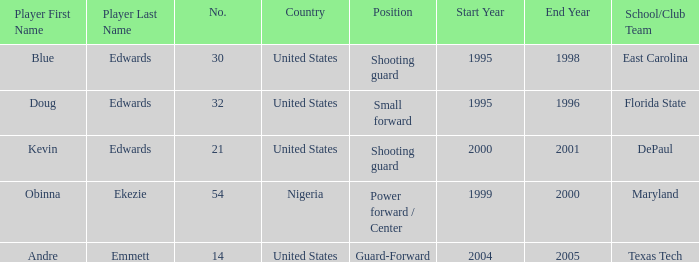When was the school/club team for grizzles was maryland 1999-2000. 